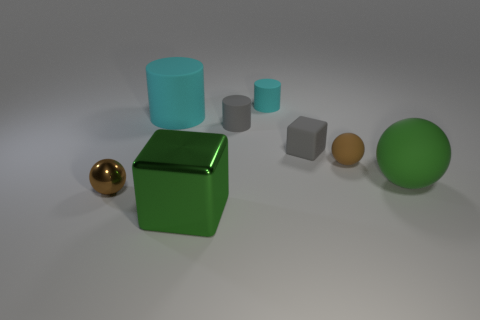Add 1 small brown metal balls. How many objects exist? 9 Subtract all balls. How many objects are left? 5 Subtract all big green matte spheres. Subtract all cyan rubber cylinders. How many objects are left? 5 Add 1 small brown things. How many small brown things are left? 3 Add 2 large cylinders. How many large cylinders exist? 3 Subtract 0 blue cylinders. How many objects are left? 8 